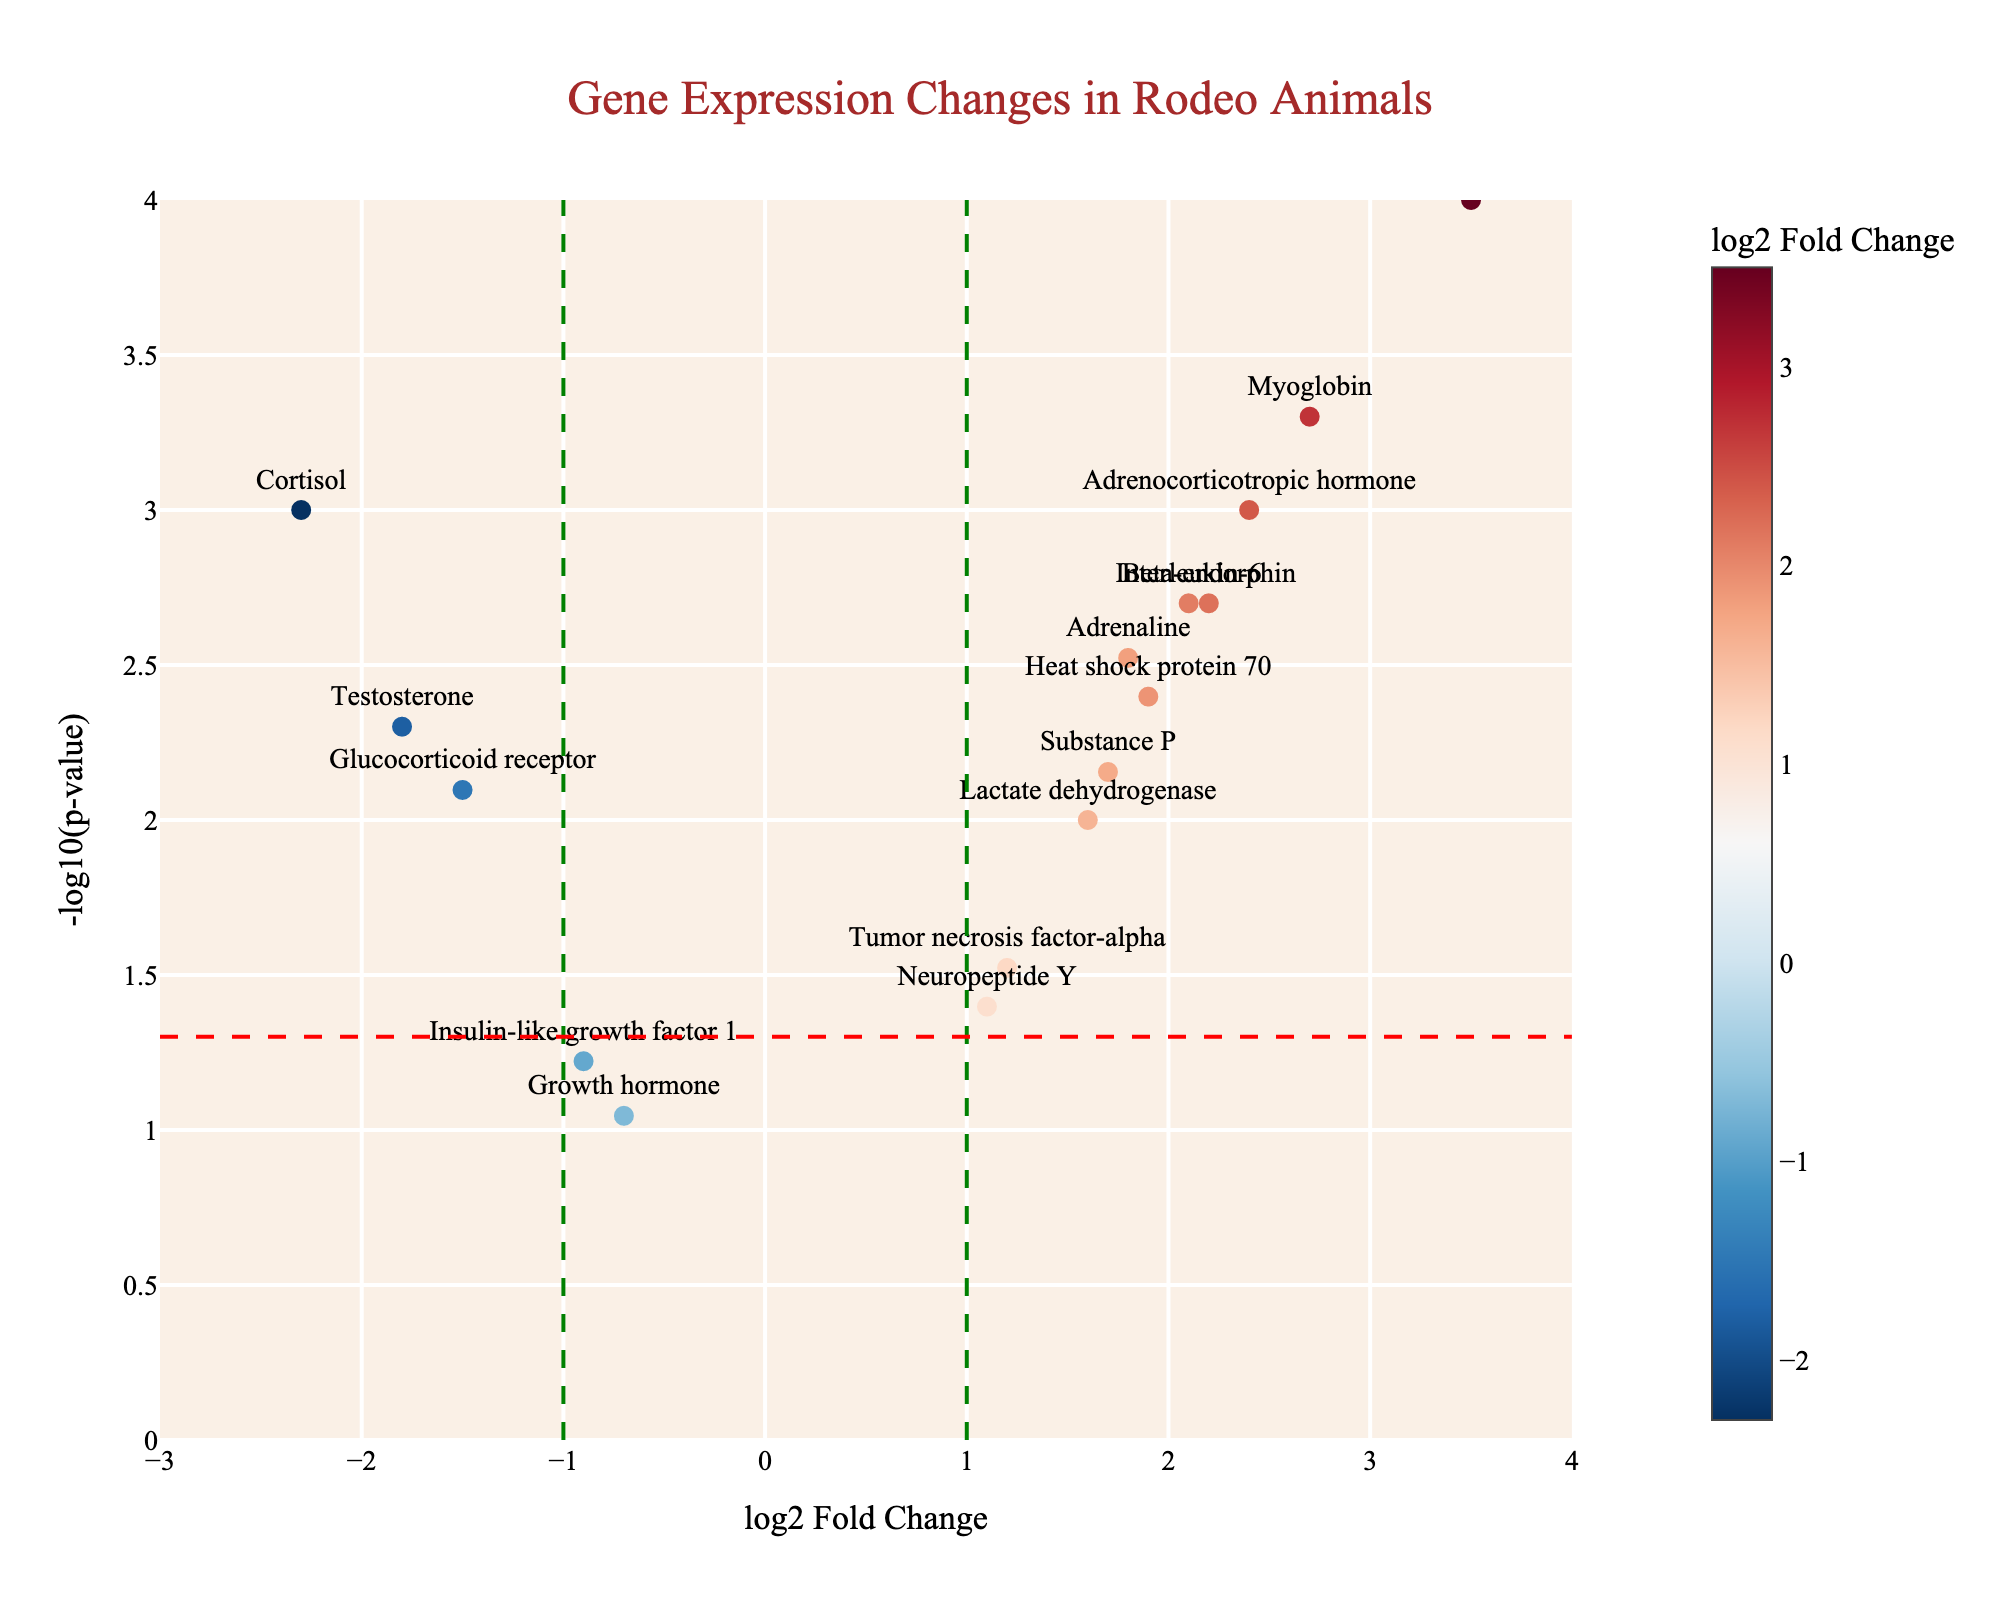How many genes exhibit significant changes in expression with p-values less than 0.05? Genes with p-values less than 0.05 are above the horizontal red dashed line. By counting, there are 12 data points above this line.
Answer: 12 Which gene has the most significant increase in expression? The most significant increase in expression would be a gene with the highest positive log2FoldChange and a low p-value. Creatine kinase has the highest log2FoldChange of 3.5 and a low p-value, making this the gene with the most significant increase.
Answer: Creatine kinase What is the log2FoldChange value of the gene with the highest significance? The highest significance corresponds to the lowest p-value. The smallest p-value (-log10(pvalue)  of 4) corresponds to Creatine kinase, which has a log2FoldChange value of 3.5.
Answer: 3.5 Which genes have a log2FoldChange value less than -1? To find these, look for data points to the left of the green dashed vertical line at log2FoldChange = -1. These genes include Cortisol, Glucocorticoid receptor, and Testosterone.
Answer: Cortisol, Glucocorticoid receptor, Testosterone Is there any gene overlapping the threshold of -log10(pvalue) = 1.3 with a log2FoldChange greater than 1.5? First, identify the horizontal threshold of -log10(pvalue) = 1.3 (which corresponds to p-value = 0.05 colored in red). Creatine kinase and Myoglobin have values greater than 1.5 above this threshold.
Answer: Creatine kinase, Myoglobin What are the genes that have a decreased expression after the event? Decreased expression corresponds to negative log2FoldChange values. These genes include Cortisol, Glucocorticoid receptor, Insulin-like growth factor 1, and Testosterone.
Answer: Cortisol, Glucocorticoid receptor, Insulin-like growth factor 1, Testosterone Which gene has the lowest -log10(p-value) and what is its value? The lowest -log10(pvalue) will be the lowest point on the y-axis. Neuropeptide Y is the gene with an approximately -log10(p-value) value of 1.4.
Answer: Neuropeptide Y What is the average log2FoldChange value of genes that have a p-value less than 0.01? Genes with p-values less than 0.01 are above the red dashed line. These genes are, Cortisol (-2.3), Adrenaline (1.8), Interleukin-6 (2.1), Creatine kinase (3.5), Heat shock protein 70 (1.9), Myoglobin (2.7), Glucocorticoid receptor (-1.5), Beta-endorphin (2.2), Adrenocorticotropic hormone (2.4), and Testosterone (-1.8). The sum is -2.3 + 1.8 + 2.1 + 3.5 + 1.9 + 2.7 - 1.5 + 2.2 + 2.4 - 1.8 = 11.
Answer: 1.1 What is the median log2FoldChange value of all the genes? To find the median log2FoldChange, list all the values and find the middle value. Values are: -2.3, -1.8, -1.5, -0.9, -0.7, 1.1, 1.2, 1.6, 1.7, 1.8, 1.9, 2.1, 2.2, 2.4, 2.7, 3.5. Total of 16 values, two middle ones 1.7 and 1.8. Average of the middle two is (1.7 + 1.8) / 2 = 1.75.
Answer: 1.75 